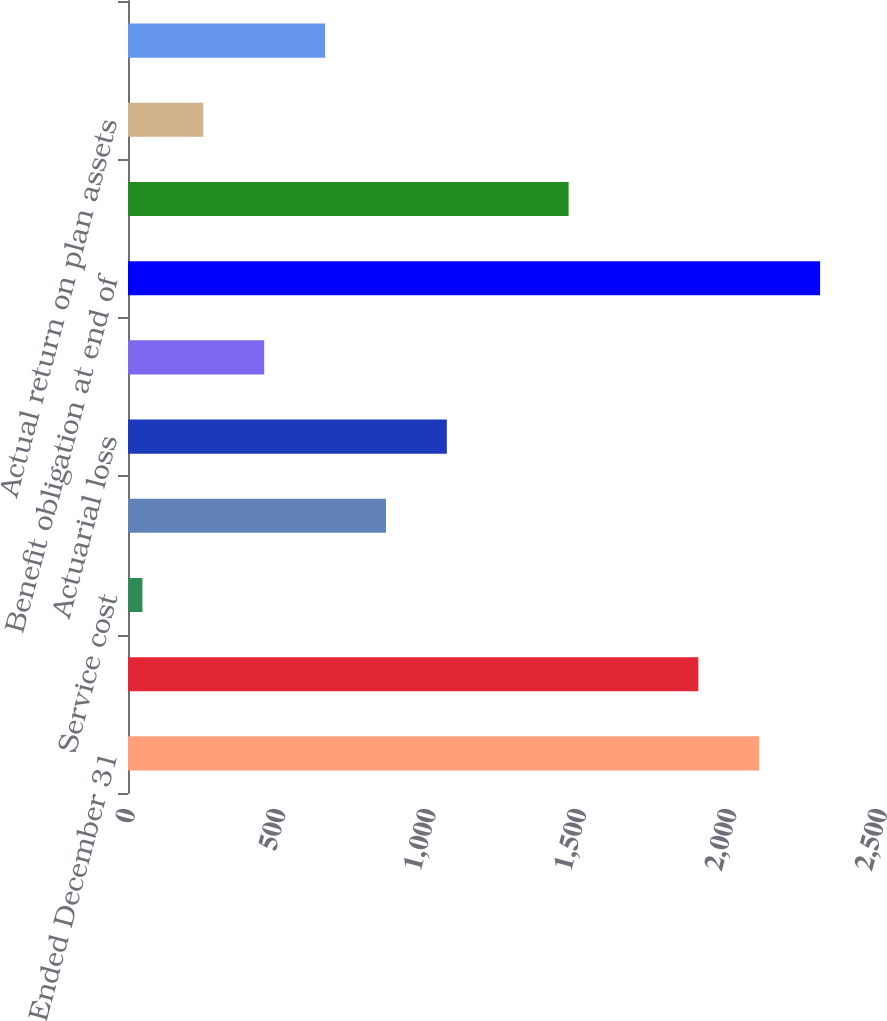Convert chart. <chart><loc_0><loc_0><loc_500><loc_500><bar_chart><fcel>Years Ended December 31<fcel>Benefit obligation at<fcel>Service cost<fcel>Interest cost<fcel>Actuarial loss<fcel>Benefits paid<fcel>Benefit obligation at end of<fcel>Plan assets at fair value at<fcel>Actual return on plan assets<fcel>Actual benefits paid<nl><fcel>2098.4<fcel>1896<fcel>48<fcel>857.6<fcel>1060<fcel>452.8<fcel>2300.8<fcel>1464.8<fcel>250.4<fcel>655.2<nl></chart> 